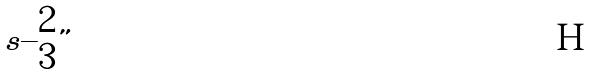Convert formula to latex. <formula><loc_0><loc_0><loc_500><loc_500>s \{ \begin{matrix} 2 \\ 3 \end{matrix} \}</formula> 